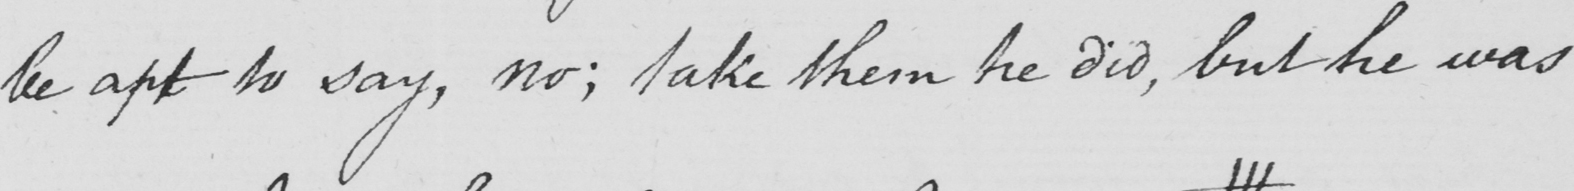Please transcribe the handwritten text in this image. be apt to say , no ; take them he did , but he was 